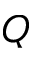Convert formula to latex. <formula><loc_0><loc_0><loc_500><loc_500>Q</formula> 